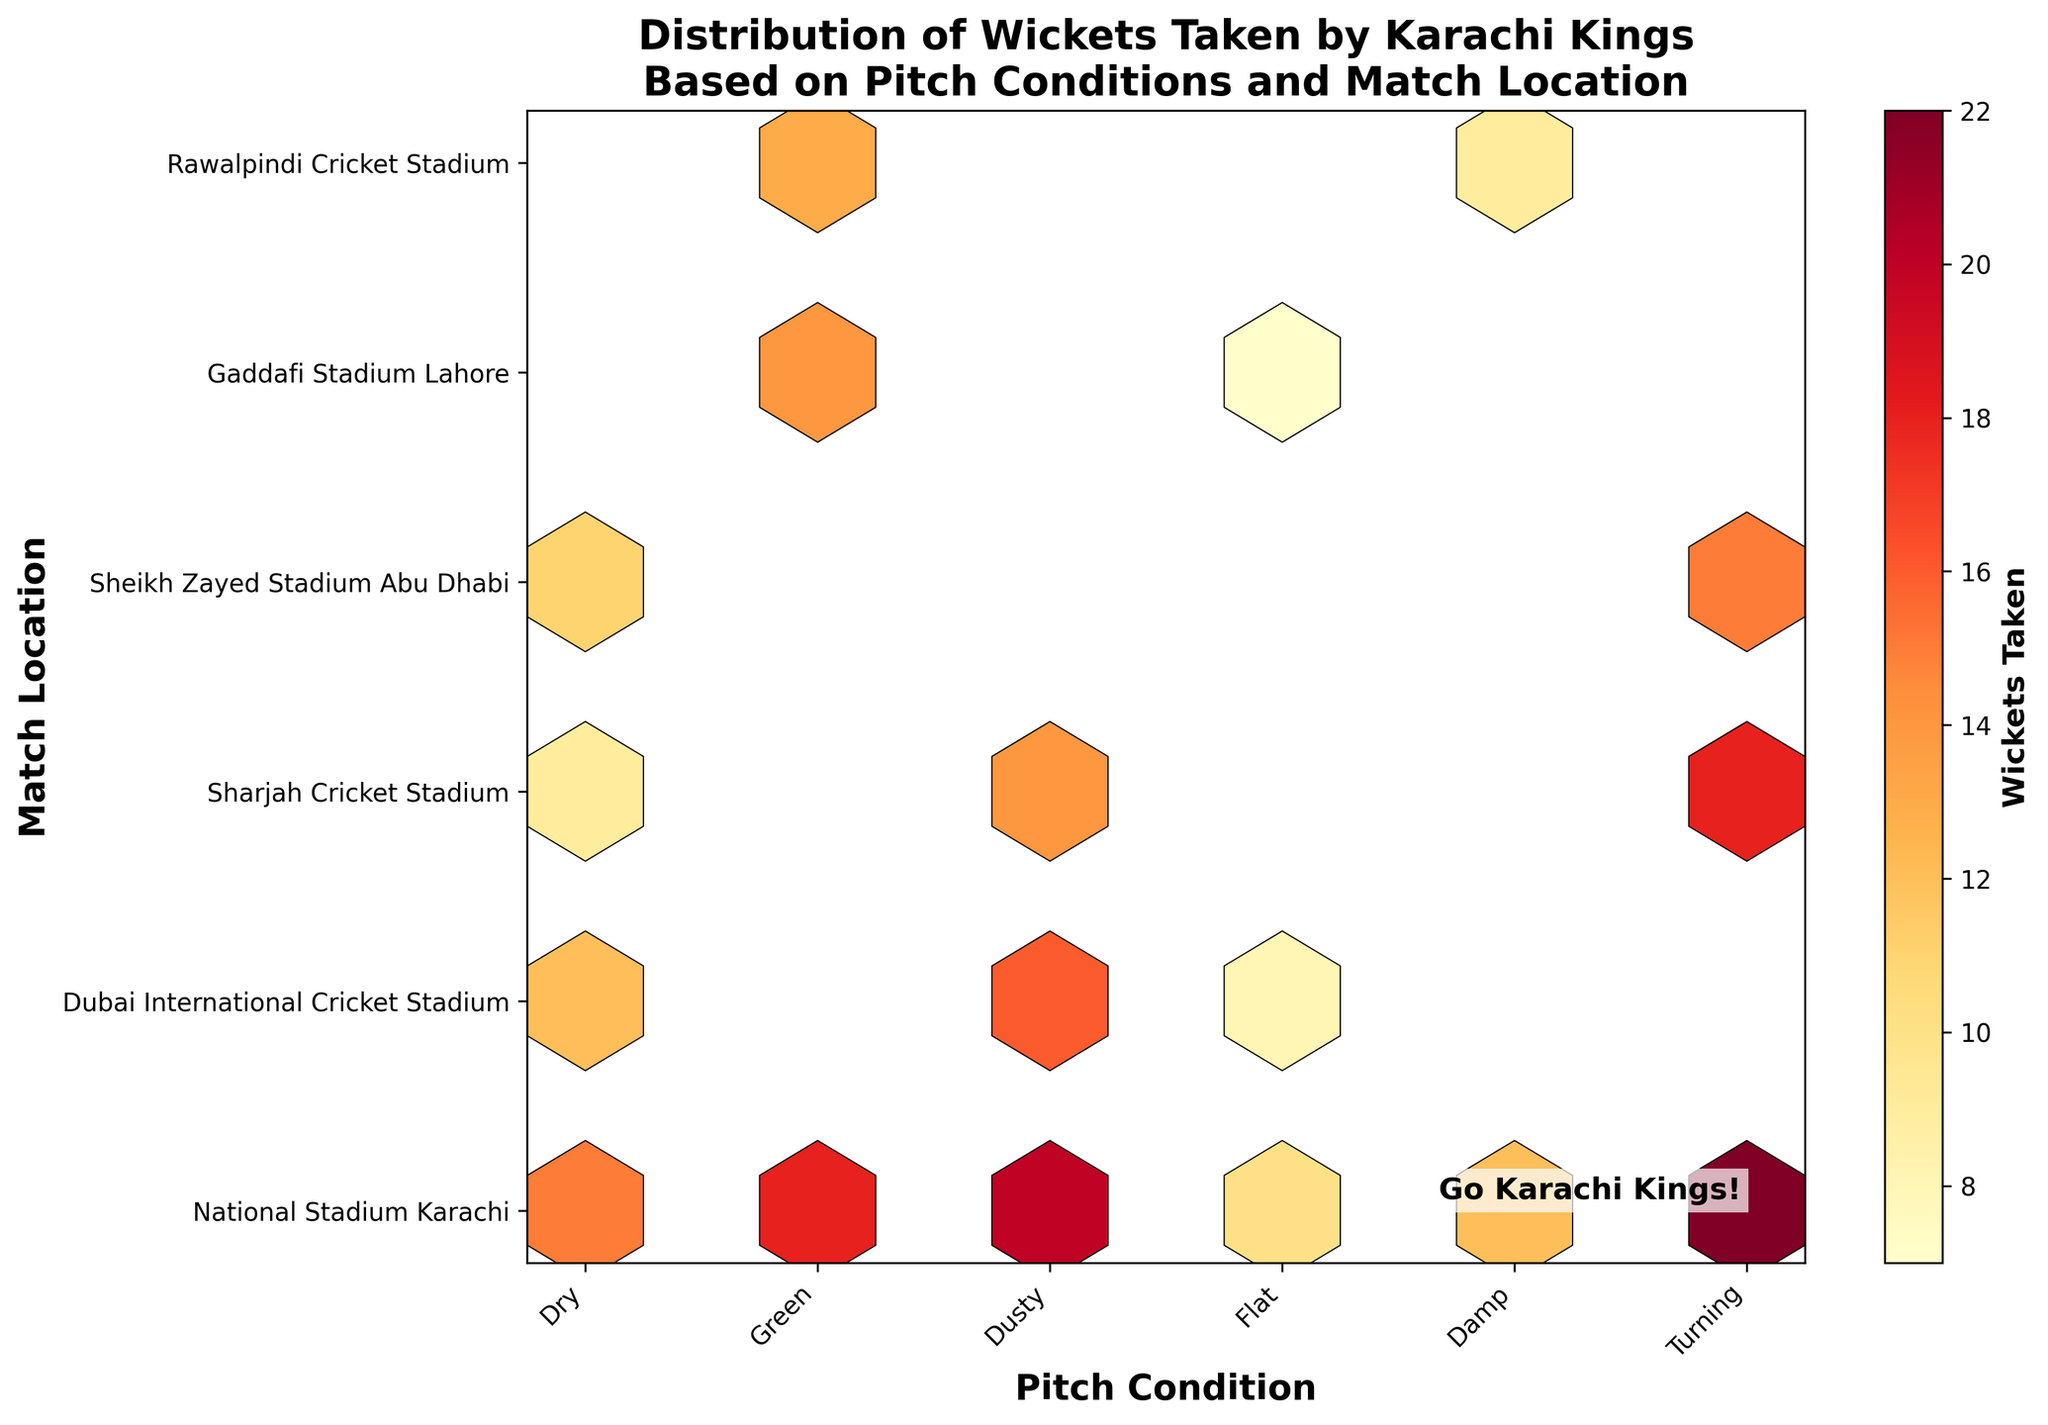What is the title of the figure? The title of the figure is typically located at the top of the plot. In this case, the title specifies what the data represents and includes "Distribution of Wickets Taken by Karachi Kings Based on Pitch Conditions and Match Location".
Answer: Distribution of Wickets Taken by Karachi Kings Based on Pitch Conditions and Match Location What do the hexagons represent in the hexbin plot? The hexagons in a hexbin plot represent the counts or sums of data points that fall into each hexagonal bin. In this figure, the color intensity of each hexagon represents the number of wickets taken by Karachi Kings' bowlers.
Answer: Number of wickets taken Which pitch condition and match location show the highest number of wickets taken? By observing the color intensity of the hexagons, the hexagon representing "Turning" pitch conditions at "National Stadium Karachi" has the darkest color, indicating the highest number of wickets taken.
Answer: Turning pitch condition at National Stadium Karachi How does the wicket count compare between "Dry" and "Dusty" pitch conditions at National Stadium Karachi? Comparing the hexagons for "Dry" and "Dusty" pitch conditions at "National Stadium Karachi", the "Dusty" condition has a darker hexagon, indicating a higher number of wickets taken.
Answer: Dusty has more wickets taken In which match location did Karachi Kings take the second highest number of wickets on a "Turning" pitch? To identify the second highest, locate the hexagons for "Turning" pitch conditions across different locations. The second darkest hexagon is at "Sharjah Cricket Stadium".
Answer: Sharjah Cricket Stadium What are the x-axis and y-axis labels on the figure? The x-axis and y-axis labels describe what is being plotted. In this figure, the x-axis label is "Pitch Condition" and the y-axis label is "Match Location".
Answer: Pitch Condition (x-axis) and Match Location (y-axis) Which match location shows the lowest number of wickets taken on a "Flat" pitch? By evaluating the hexagon colors for "Flat" pitch conditions, the location with the lightest (least intense) hexagon color is "Gaddafi Stadium Lahore".
Answer: Gaddafi Stadium Lahore How many different pitch conditions and match locations are represented in the plot? The x-axis and y-axis ticks will provide this information. There are 6 different pitch conditions (Dry, Green, Dusty, Flat, Damp, Turning) and 6 different match locations.
Answer: 6 pitch conditions and 6 match locations What pitch conditions lead to more wickets taken in "National Stadium Karachi"? Comparing the hexagons for different pitch conditions at "National Stadium Karachi", "Dusty" and "Turning" conditions have the most intense colors, indicating more wickets taken.
Answer: Dusty and Turning 